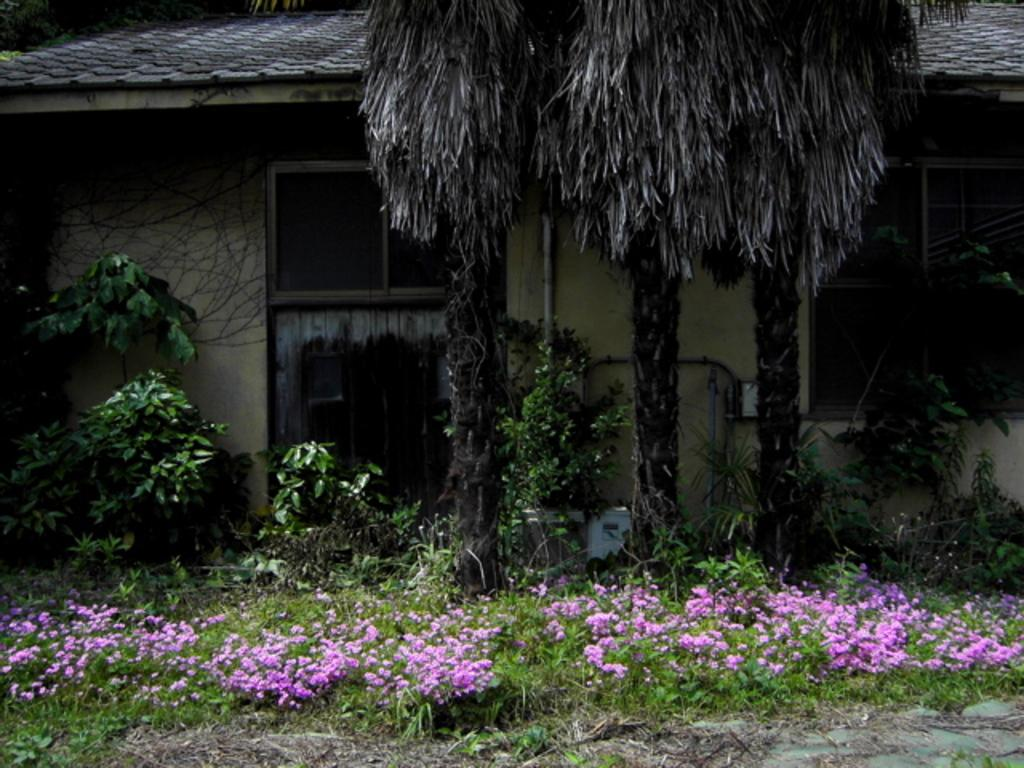What type of outdoor space is shown in the image? There is a garden in the image. What type of plant can be seen in the garden? There is a tree in the image. What structure is visible in the background of the image? There is a house in the background of the image. What type of nerve can be seen in the image? There is no nerve present in the image. The image features a garden, a tree, and a house in the background. 